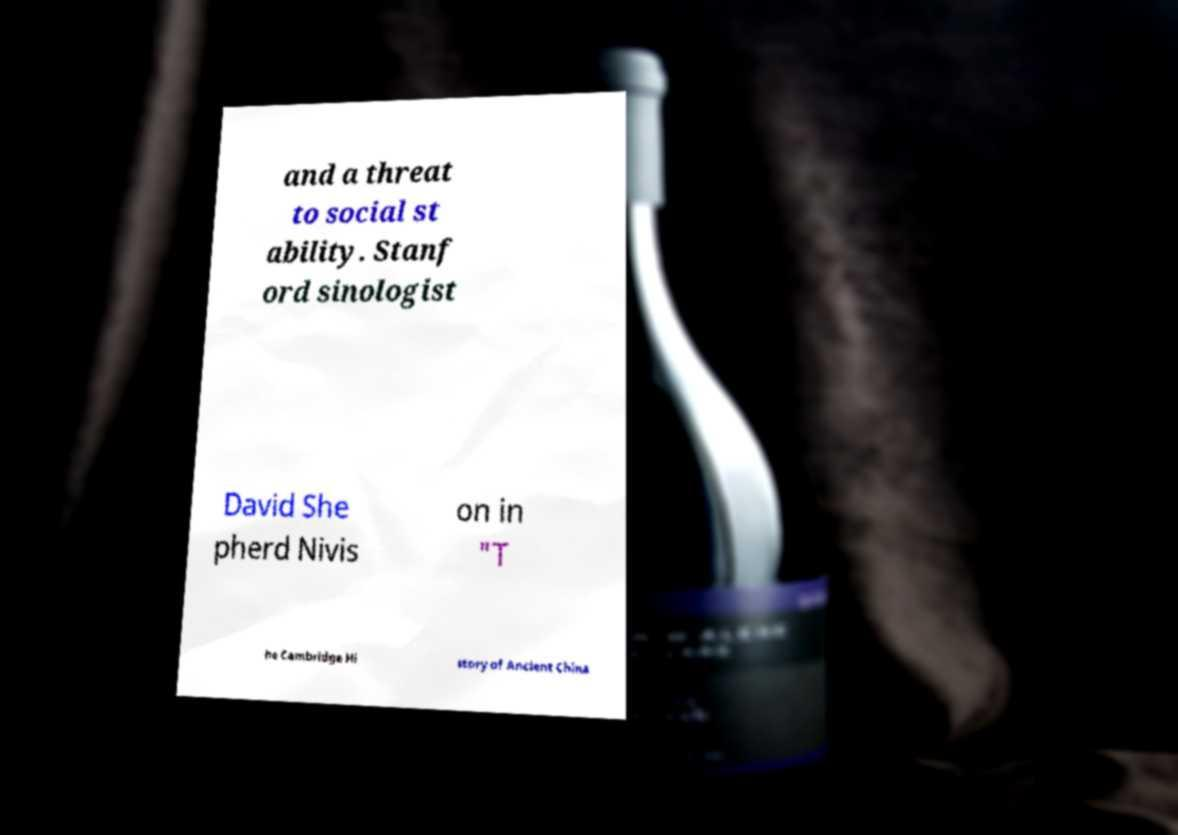Could you extract and type out the text from this image? and a threat to social st ability. Stanf ord sinologist David She pherd Nivis on in "T he Cambridge Hi story of Ancient China 